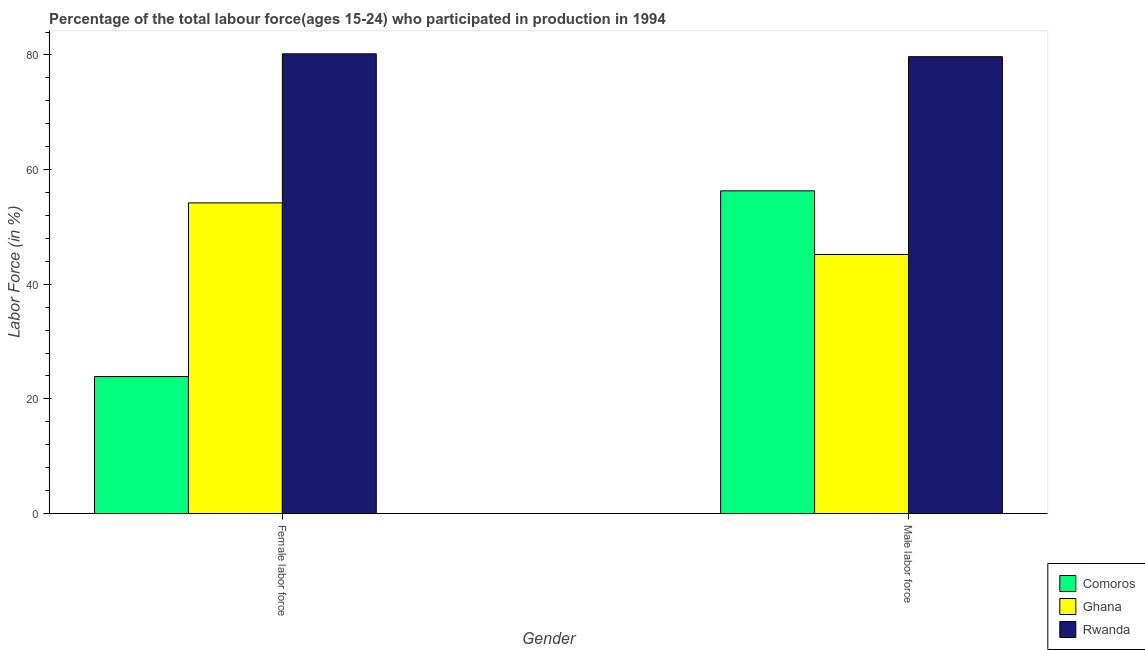How many groups of bars are there?
Provide a succinct answer. 2. How many bars are there on the 2nd tick from the left?
Give a very brief answer. 3. What is the label of the 1st group of bars from the left?
Your answer should be compact. Female labor force. What is the percentage of female labor force in Rwanda?
Offer a terse response. 80.2. Across all countries, what is the maximum percentage of male labour force?
Offer a very short reply. 79.7. Across all countries, what is the minimum percentage of male labour force?
Provide a short and direct response. 45.2. In which country was the percentage of female labor force maximum?
Offer a very short reply. Rwanda. In which country was the percentage of female labor force minimum?
Keep it short and to the point. Comoros. What is the total percentage of female labor force in the graph?
Ensure brevity in your answer.  158.3. What is the difference between the percentage of male labour force in Comoros and that in Rwanda?
Offer a very short reply. -23.4. What is the difference between the percentage of female labor force in Ghana and the percentage of male labour force in Rwanda?
Ensure brevity in your answer.  -25.5. What is the average percentage of female labor force per country?
Offer a very short reply. 52.77. What is the ratio of the percentage of male labour force in Ghana to that in Comoros?
Your answer should be very brief. 0.8. Is the percentage of male labour force in Comoros less than that in Rwanda?
Give a very brief answer. Yes. What does the 3rd bar from the left in Male labor force represents?
Provide a succinct answer. Rwanda. How many bars are there?
Keep it short and to the point. 6. Are all the bars in the graph horizontal?
Offer a terse response. No. What is the difference between two consecutive major ticks on the Y-axis?
Offer a terse response. 20. Does the graph contain grids?
Your response must be concise. No. How many legend labels are there?
Provide a short and direct response. 3. How are the legend labels stacked?
Provide a short and direct response. Vertical. What is the title of the graph?
Offer a very short reply. Percentage of the total labour force(ages 15-24) who participated in production in 1994. Does "High income: nonOECD" appear as one of the legend labels in the graph?
Make the answer very short. No. What is the label or title of the X-axis?
Your answer should be compact. Gender. What is the Labor Force (in %) of Comoros in Female labor force?
Give a very brief answer. 23.9. What is the Labor Force (in %) in Ghana in Female labor force?
Ensure brevity in your answer.  54.2. What is the Labor Force (in %) of Rwanda in Female labor force?
Your answer should be very brief. 80.2. What is the Labor Force (in %) of Comoros in Male labor force?
Your response must be concise. 56.3. What is the Labor Force (in %) of Ghana in Male labor force?
Make the answer very short. 45.2. What is the Labor Force (in %) of Rwanda in Male labor force?
Your answer should be compact. 79.7. Across all Gender, what is the maximum Labor Force (in %) in Comoros?
Keep it short and to the point. 56.3. Across all Gender, what is the maximum Labor Force (in %) of Ghana?
Offer a very short reply. 54.2. Across all Gender, what is the maximum Labor Force (in %) of Rwanda?
Give a very brief answer. 80.2. Across all Gender, what is the minimum Labor Force (in %) in Comoros?
Keep it short and to the point. 23.9. Across all Gender, what is the minimum Labor Force (in %) of Ghana?
Your response must be concise. 45.2. Across all Gender, what is the minimum Labor Force (in %) of Rwanda?
Give a very brief answer. 79.7. What is the total Labor Force (in %) of Comoros in the graph?
Give a very brief answer. 80.2. What is the total Labor Force (in %) of Ghana in the graph?
Give a very brief answer. 99.4. What is the total Labor Force (in %) of Rwanda in the graph?
Give a very brief answer. 159.9. What is the difference between the Labor Force (in %) of Comoros in Female labor force and that in Male labor force?
Your response must be concise. -32.4. What is the difference between the Labor Force (in %) in Ghana in Female labor force and that in Male labor force?
Offer a very short reply. 9. What is the difference between the Labor Force (in %) of Rwanda in Female labor force and that in Male labor force?
Offer a very short reply. 0.5. What is the difference between the Labor Force (in %) in Comoros in Female labor force and the Labor Force (in %) in Ghana in Male labor force?
Ensure brevity in your answer.  -21.3. What is the difference between the Labor Force (in %) of Comoros in Female labor force and the Labor Force (in %) of Rwanda in Male labor force?
Your answer should be very brief. -55.8. What is the difference between the Labor Force (in %) of Ghana in Female labor force and the Labor Force (in %) of Rwanda in Male labor force?
Offer a very short reply. -25.5. What is the average Labor Force (in %) of Comoros per Gender?
Provide a short and direct response. 40.1. What is the average Labor Force (in %) of Ghana per Gender?
Offer a terse response. 49.7. What is the average Labor Force (in %) in Rwanda per Gender?
Give a very brief answer. 79.95. What is the difference between the Labor Force (in %) of Comoros and Labor Force (in %) of Ghana in Female labor force?
Ensure brevity in your answer.  -30.3. What is the difference between the Labor Force (in %) in Comoros and Labor Force (in %) in Rwanda in Female labor force?
Give a very brief answer. -56.3. What is the difference between the Labor Force (in %) in Comoros and Labor Force (in %) in Ghana in Male labor force?
Provide a succinct answer. 11.1. What is the difference between the Labor Force (in %) of Comoros and Labor Force (in %) of Rwanda in Male labor force?
Offer a terse response. -23.4. What is the difference between the Labor Force (in %) in Ghana and Labor Force (in %) in Rwanda in Male labor force?
Provide a short and direct response. -34.5. What is the ratio of the Labor Force (in %) in Comoros in Female labor force to that in Male labor force?
Offer a very short reply. 0.42. What is the ratio of the Labor Force (in %) of Ghana in Female labor force to that in Male labor force?
Your answer should be very brief. 1.2. What is the difference between the highest and the second highest Labor Force (in %) of Comoros?
Make the answer very short. 32.4. What is the difference between the highest and the second highest Labor Force (in %) of Ghana?
Keep it short and to the point. 9. What is the difference between the highest and the second highest Labor Force (in %) of Rwanda?
Your answer should be very brief. 0.5. What is the difference between the highest and the lowest Labor Force (in %) of Comoros?
Offer a very short reply. 32.4. 